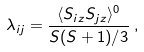<formula> <loc_0><loc_0><loc_500><loc_500>\lambda _ { i j } = \frac { \langle S _ { i z } S _ { j z } \rangle ^ { 0 } } { S ( S + 1 ) / 3 } \, ,</formula> 